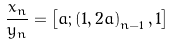<formula> <loc_0><loc_0><loc_500><loc_500>\frac { x _ { n } } { y _ { n } } = \left [ a ; \left ( 1 , 2 a \right ) _ { n - 1 } , 1 \right ]</formula> 